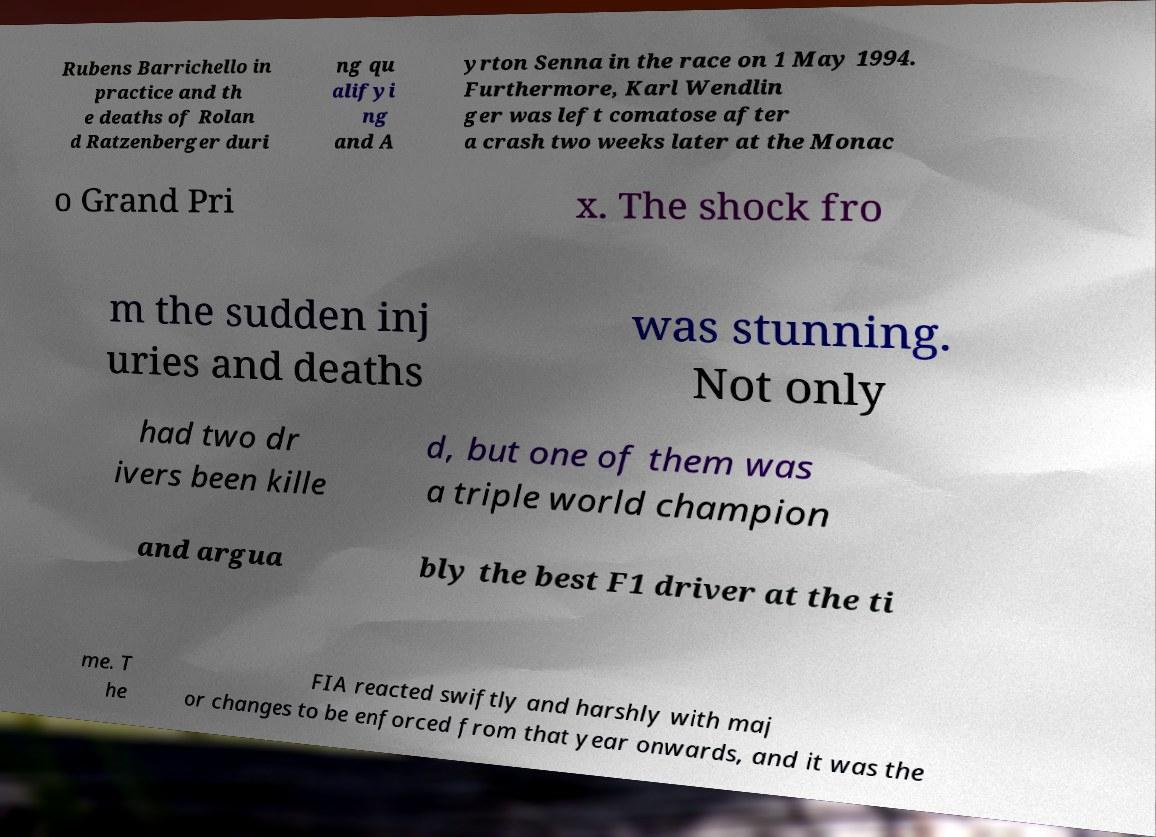Can you accurately transcribe the text from the provided image for me? Rubens Barrichello in practice and th e deaths of Rolan d Ratzenberger duri ng qu alifyi ng and A yrton Senna in the race on 1 May 1994. Furthermore, Karl Wendlin ger was left comatose after a crash two weeks later at the Monac o Grand Pri x. The shock fro m the sudden inj uries and deaths was stunning. Not only had two dr ivers been kille d, but one of them was a triple world champion and argua bly the best F1 driver at the ti me. T he FIA reacted swiftly and harshly with maj or changes to be enforced from that year onwards, and it was the 